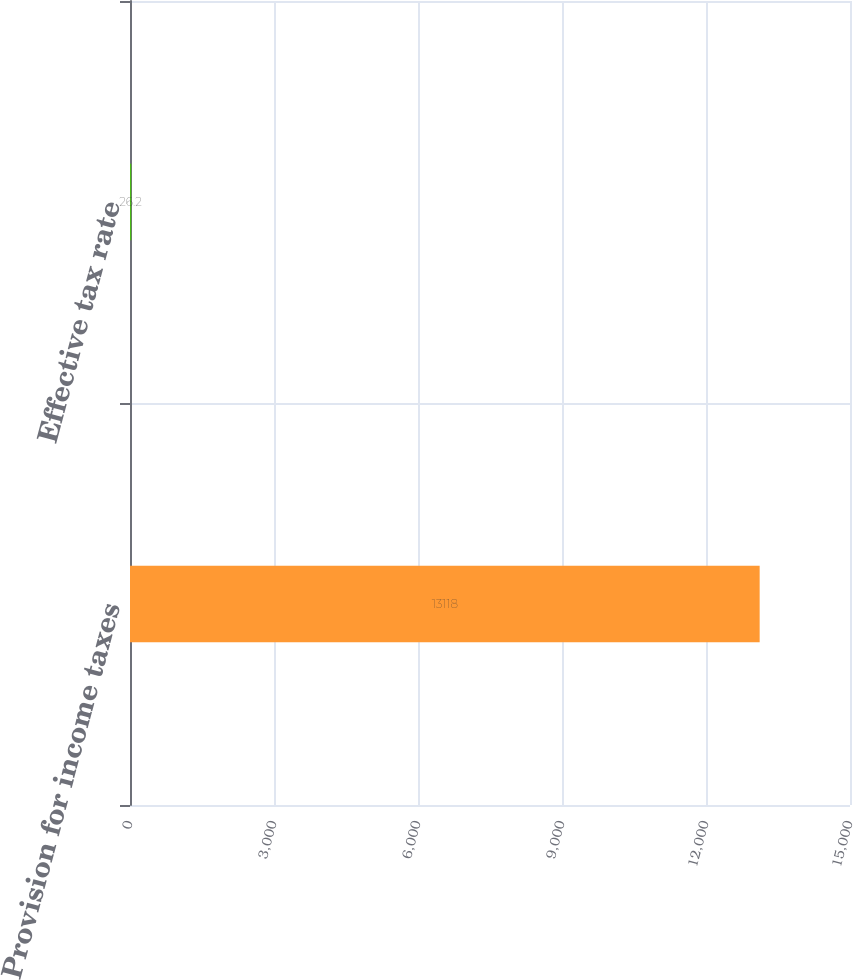Convert chart to OTSL. <chart><loc_0><loc_0><loc_500><loc_500><bar_chart><fcel>Provision for income taxes<fcel>Effective tax rate<nl><fcel>13118<fcel>26.2<nl></chart> 